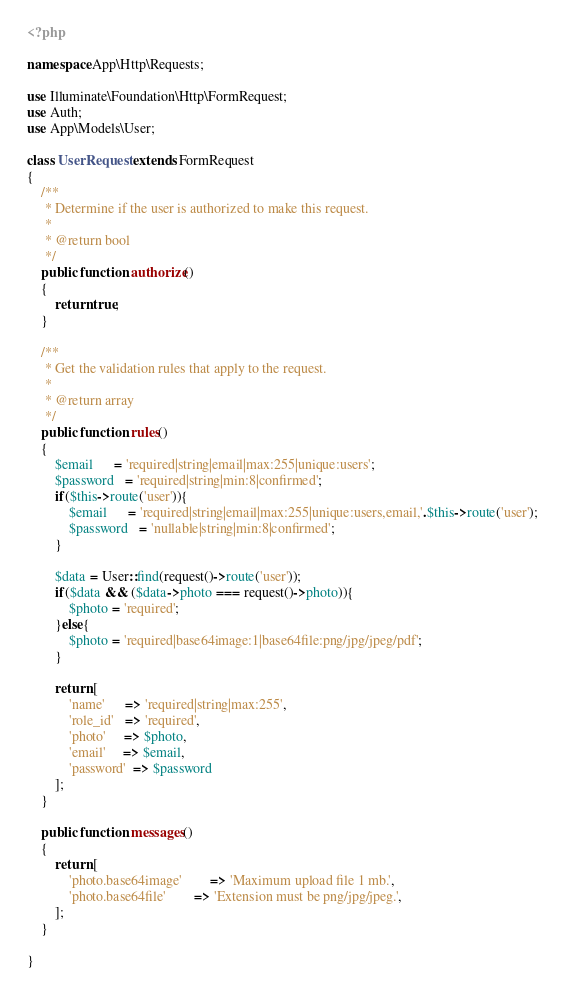Convert code to text. <code><loc_0><loc_0><loc_500><loc_500><_PHP_><?php

namespace App\Http\Requests;

use Illuminate\Foundation\Http\FormRequest;
use Auth;
use App\Models\User;

class UserRequest extends FormRequest
{
    /**
     * Determine if the user is authorized to make this request.
     *
     * @return bool
     */
    public function authorize()
    {
        return true;
    }

    /**
     * Get the validation rules that apply to the request.
     *
     * @return array
     */
    public function rules()
    {
        $email      = 'required|string|email|max:255|unique:users';
        $password   = 'required|string|min:8|confirmed';
        if($this->route('user')){
            $email      = 'required|string|email|max:255|unique:users,email,'.$this->route('user');
            $password   = 'nullable|string|min:8|confirmed';
        }

        $data = User::find(request()->route('user'));
        if($data && ($data->photo === request()->photo)){
            $photo = 'required';
        }else{
            $photo = 'required|base64image:1|base64file:png/jpg/jpeg/pdf';
        }

        return [
            'name'      => 'required|string|max:255',
            'role_id'   => 'required',
            'photo'     => $photo,
            'email'     => $email,
            'password'  => $password
        ];
    }

    public function messages()
    {
        return [
            'photo.base64image'        => 'Maximum upload file 1 mb.',
            'photo.base64file'        => 'Extension must be png/jpg/jpeg.',
        ];
    }

}
</code> 